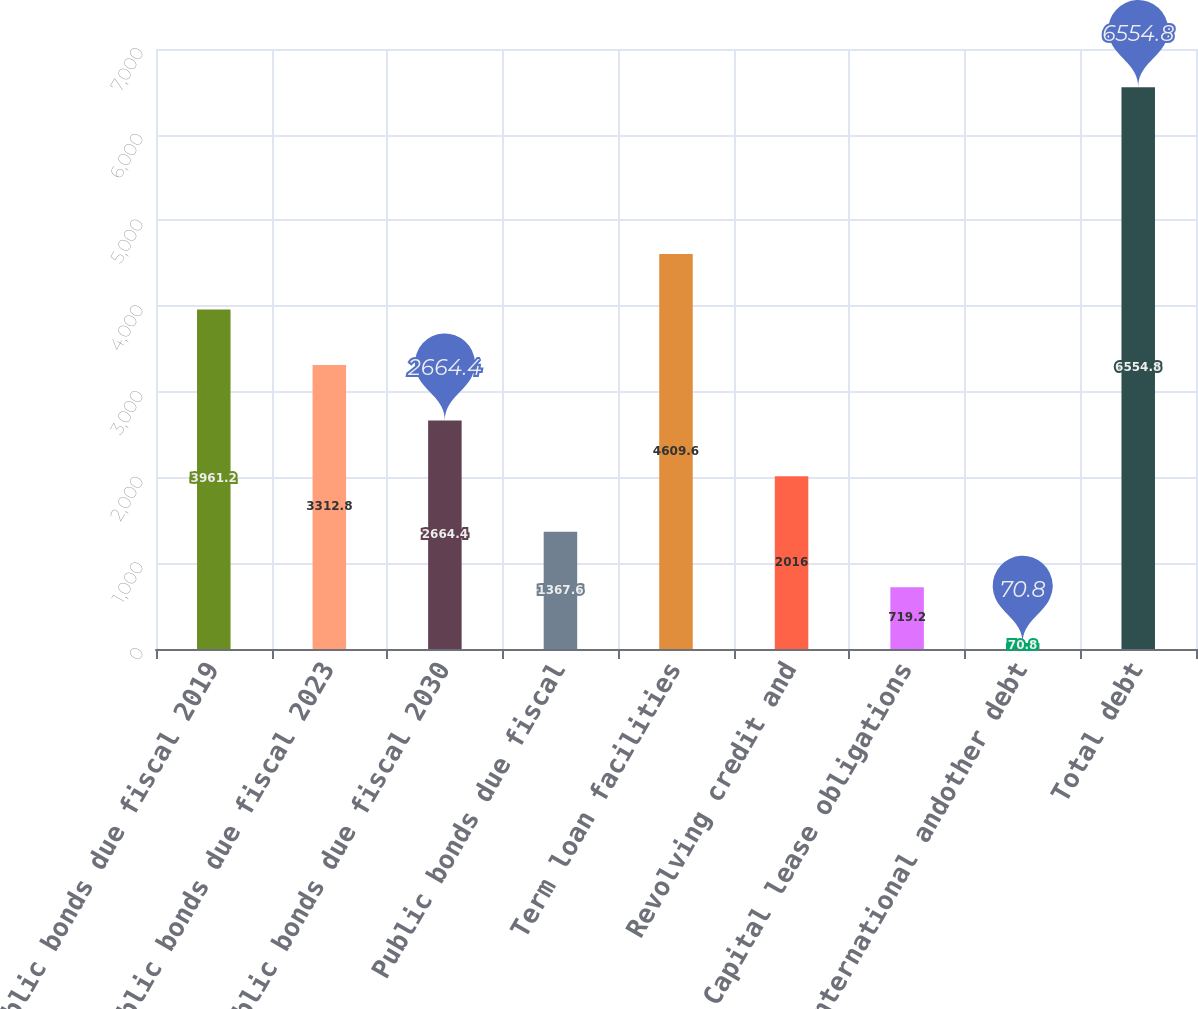<chart> <loc_0><loc_0><loc_500><loc_500><bar_chart><fcel>Public bonds due fiscal 2019<fcel>Public bonds due fiscal 2023<fcel>Public bonds due fiscal 2030<fcel>Public bonds due fiscal<fcel>Term loan facilities<fcel>Revolving credit and<fcel>Capital lease obligations<fcel>International andother debt<fcel>Total debt<nl><fcel>3961.2<fcel>3312.8<fcel>2664.4<fcel>1367.6<fcel>4609.6<fcel>2016<fcel>719.2<fcel>70.8<fcel>6554.8<nl></chart> 